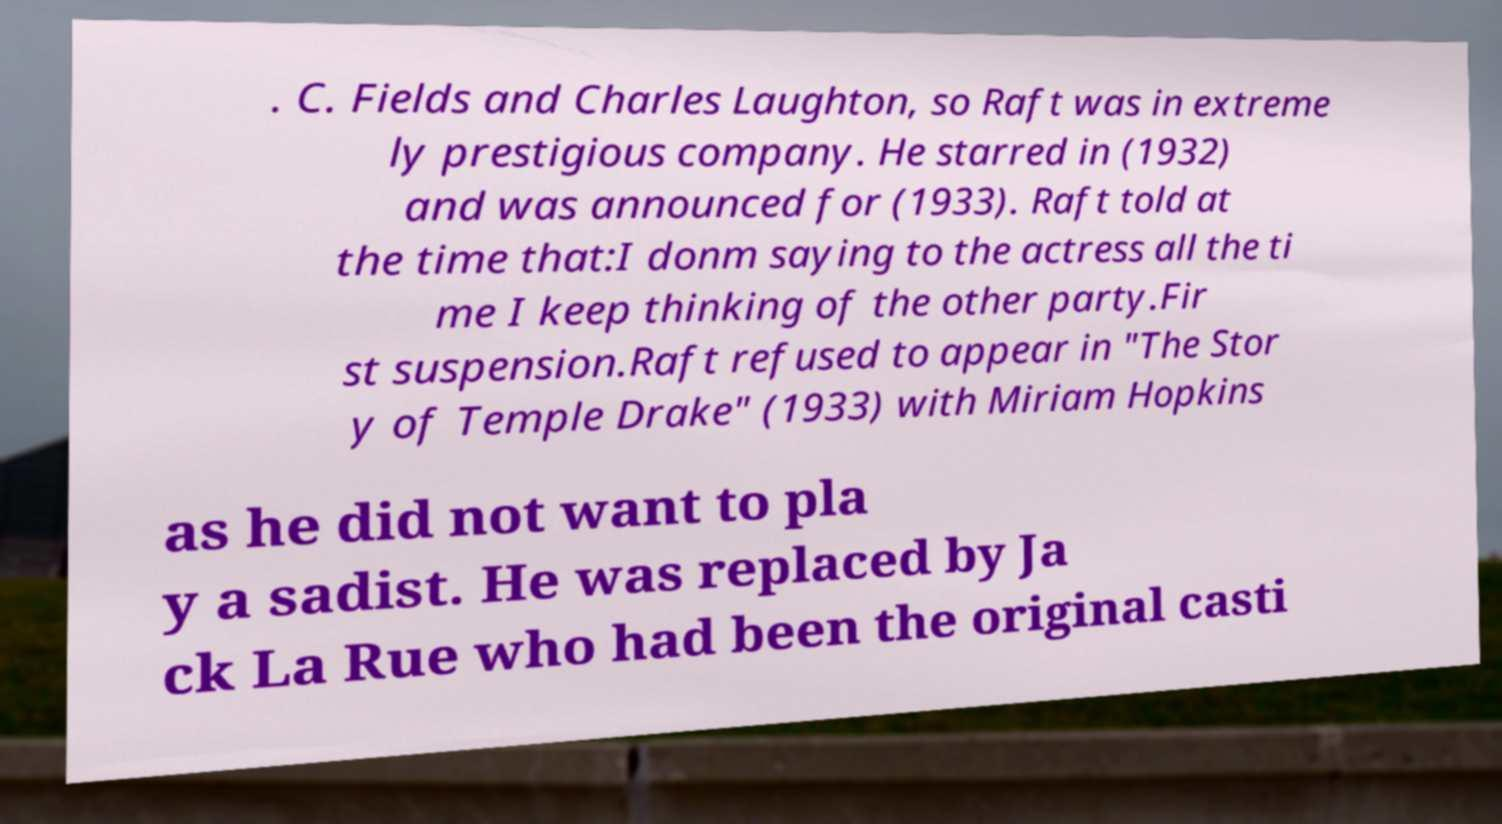What messages or text are displayed in this image? I need them in a readable, typed format. . C. Fields and Charles Laughton, so Raft was in extreme ly prestigious company. He starred in (1932) and was announced for (1933). Raft told at the time that:I donm saying to the actress all the ti me I keep thinking of the other party.Fir st suspension.Raft refused to appear in "The Stor y of Temple Drake" (1933) with Miriam Hopkins as he did not want to pla y a sadist. He was replaced by Ja ck La Rue who had been the original casti 